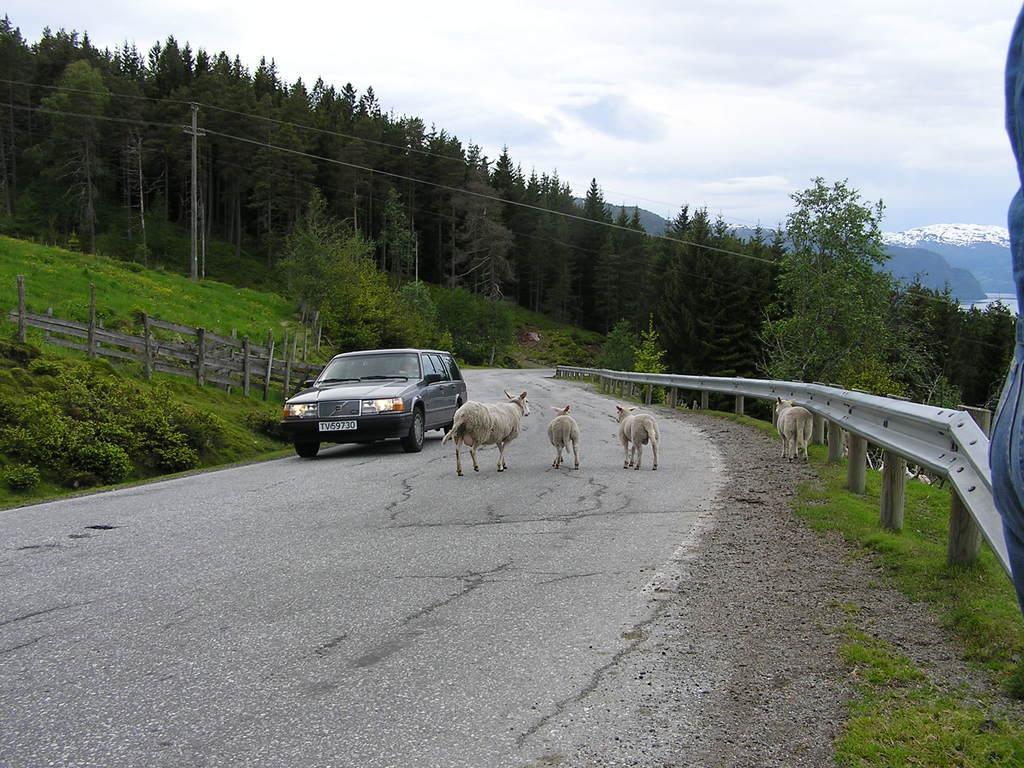Please provide a concise description of this image. There is a road. On that there is a car and animals. On the side there is a railing. Also there are plants, trees, electric pole, sky and hills. 